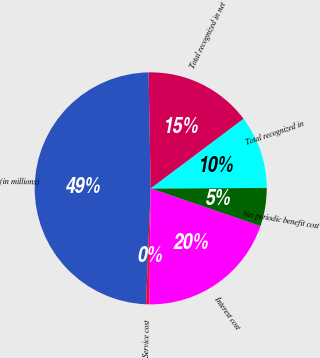Convert chart to OTSL. <chart><loc_0><loc_0><loc_500><loc_500><pie_chart><fcel>(in millions)<fcel>Service cost<fcel>Interest cost<fcel>Net periodic benefit cost<fcel>Total recognized in<fcel>Total recognized in net<nl><fcel>49.07%<fcel>0.46%<fcel>19.91%<fcel>5.32%<fcel>10.19%<fcel>15.05%<nl></chart> 